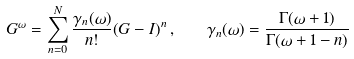<formula> <loc_0><loc_0><loc_500><loc_500>G ^ { \omega } = \sum _ { n = 0 } ^ { N } \frac { \gamma _ { n } ( \omega ) } { n ! } { ( G - I ) } ^ { n } \, , \quad \gamma _ { n } ( \omega ) = \frac { \Gamma ( \omega + 1 ) } { \Gamma ( \omega + 1 - n ) }</formula> 